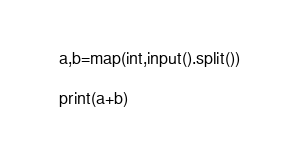Convert code to text. <code><loc_0><loc_0><loc_500><loc_500><_Python_>a,b=map(int,input().split())

print(a+b)

</code> 